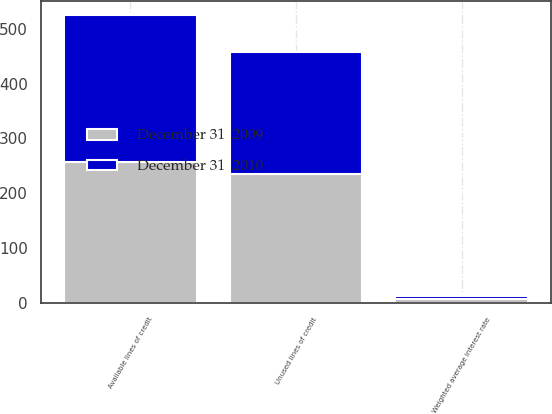Convert chart to OTSL. <chart><loc_0><loc_0><loc_500><loc_500><stacked_bar_chart><ecel><fcel>Available lines of credit<fcel>Unused lines of credit<fcel>Weighted average interest rate<nl><fcel>December 31  2009<fcel>257.8<fcel>234.3<fcel>7.4<nl><fcel>December 31  2010<fcel>267.3<fcel>224.4<fcel>5.5<nl></chart> 